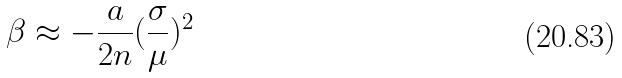<formula> <loc_0><loc_0><loc_500><loc_500>\beta \approx - \frac { a } { 2 n } ( \frac { \sigma } { \mu } ) ^ { 2 }</formula> 